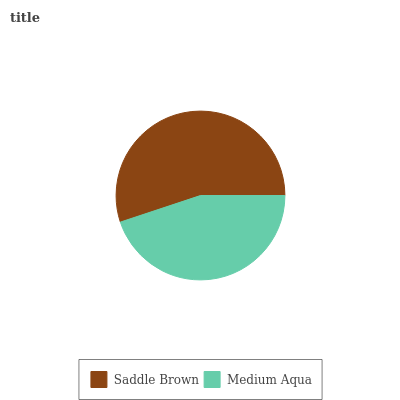Is Medium Aqua the minimum?
Answer yes or no. Yes. Is Saddle Brown the maximum?
Answer yes or no. Yes. Is Medium Aqua the maximum?
Answer yes or no. No. Is Saddle Brown greater than Medium Aqua?
Answer yes or no. Yes. Is Medium Aqua less than Saddle Brown?
Answer yes or no. Yes. Is Medium Aqua greater than Saddle Brown?
Answer yes or no. No. Is Saddle Brown less than Medium Aqua?
Answer yes or no. No. Is Saddle Brown the high median?
Answer yes or no. Yes. Is Medium Aqua the low median?
Answer yes or no. Yes. Is Medium Aqua the high median?
Answer yes or no. No. Is Saddle Brown the low median?
Answer yes or no. No. 